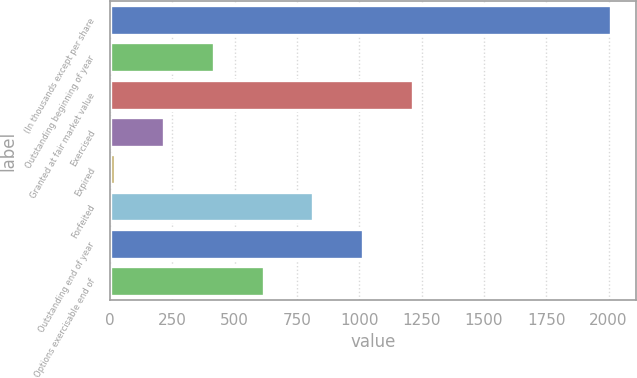Convert chart. <chart><loc_0><loc_0><loc_500><loc_500><bar_chart><fcel>(In thousands except per share<fcel>Outstanding beginning of year<fcel>Granted at fair market value<fcel>Exercised<fcel>Expired<fcel>Forfeited<fcel>Outstanding end of year<fcel>Options exercisable end of<nl><fcel>2011<fcel>417.37<fcel>1214.2<fcel>218.16<fcel>18.95<fcel>815.79<fcel>1015<fcel>616.58<nl></chart> 